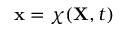<formula> <loc_0><loc_0><loc_500><loc_500>x = \chi ( X , t )</formula> 